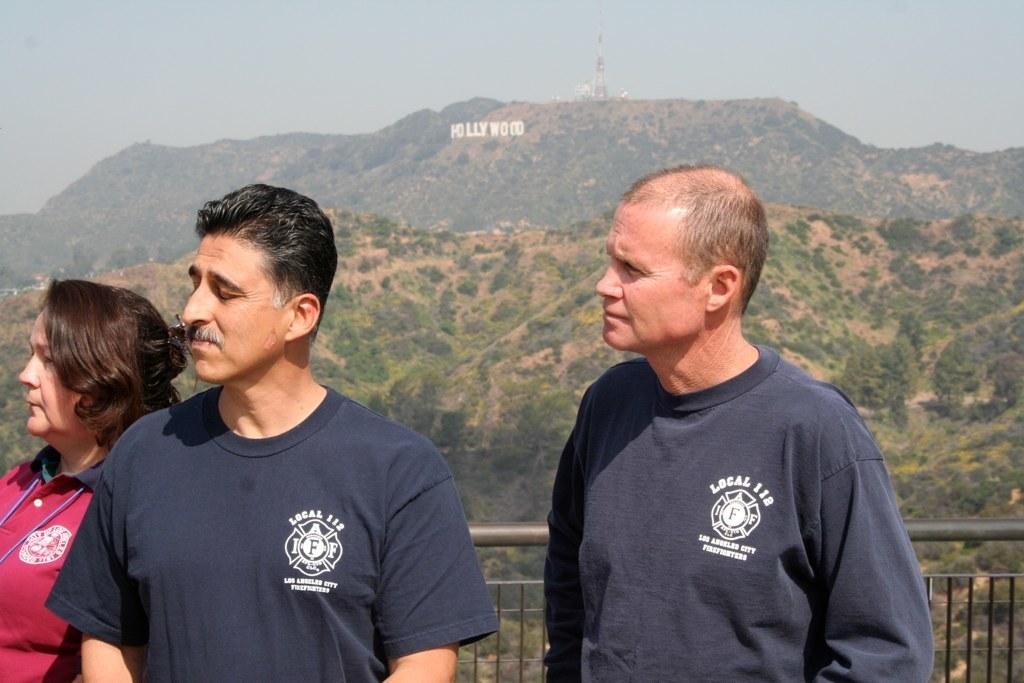How many people are in the image? There are three persons standing in the image. What is behind the persons? There is a railing behind the persons. What can be seen in the distance in the image? Mountains and trees are present in the background of the image. What is written or depicted on the mountains? There is text visible on the mountains. What is visible above the mountains and trees in the image? The sky is visible in the background of the image. What type of art can be seen blowing in the wind in the image? There is no art or wind present in the image; it features three persons standing with a railing, mountains, trees, text on the mountains, and a visible sky. 